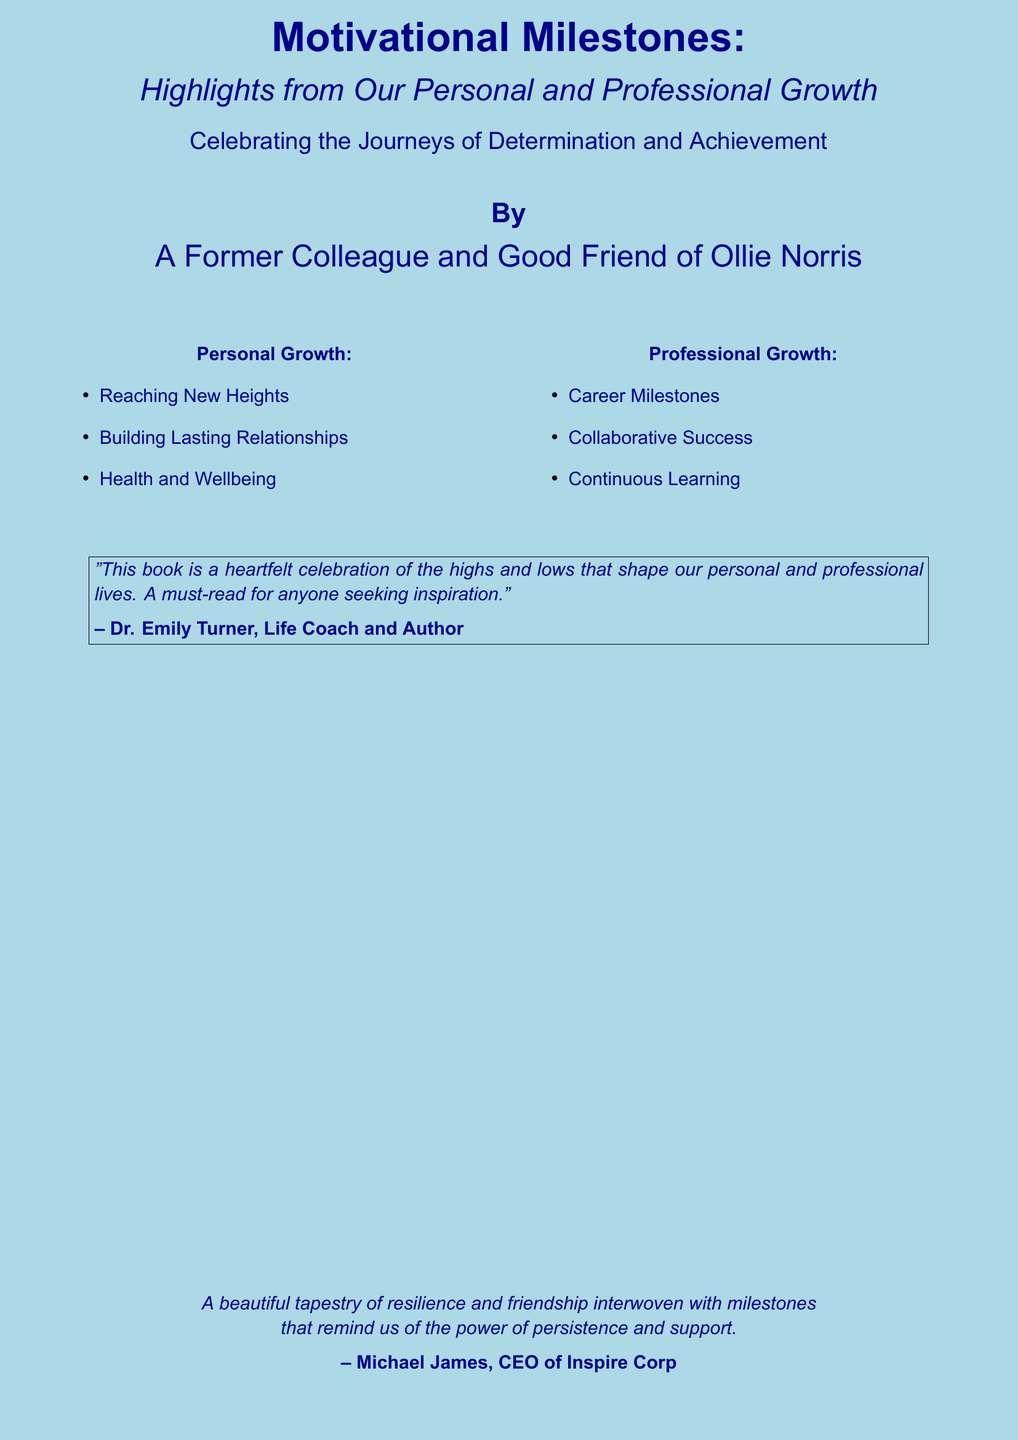What is the title of the book? The title is prominently displayed at the top of the cover and is "Motivational Milestones."
Answer: Motivational Milestones Who is the author of the book? The author's name is mentioned at the bottom of the cover as "A Former Colleague and Good Friend of Ollie Norris."
Answer: A Former Colleague and Good Friend of Ollie Norris What color is the background of the book cover? The background color of the book cover is described in the document as "lightblue."
Answer: lightblue What is one theme of personal growth highlighted in the book? The book lists several aspects of personal growth, one of which is "Health and Wellbeing."
Answer: Health and Wellbeing What type of growth does the book address besides personal growth? The book covers another area of growth, which is "Professional Growth."
Answer: Professional Growth Who provided a quote on the book cover? The quote on the book cover is attributed to "Dr. Emily Turner."
Answer: Dr. Emily Turner What is the overall message of the book according to the quotes? The quotes indicate that the book is a "heartfelt celebration of the highs and lows" in life.
Answer: heartfelt celebration of the highs and lows What is the subtitle of the book? The subtitle is listed under the title and is "Highlights from Our Personal and Professional Growth."
Answer: Highlights from Our Personal and Professional Growth What type of content does the book focus on regarding the journeys? The cover mentions the content focuses on "Determination and Achievement."
Answer: Determination and Achievement 